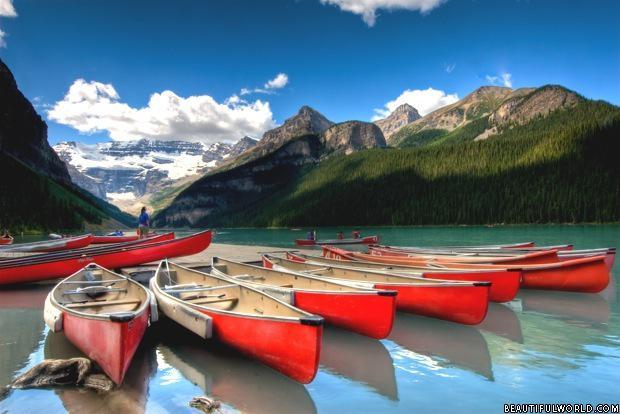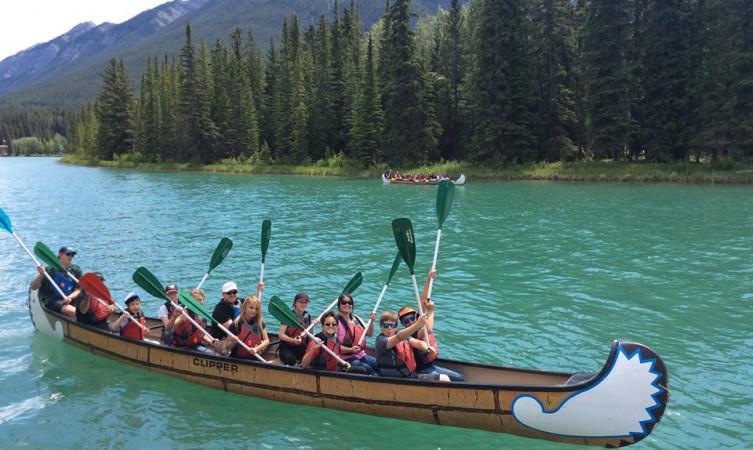The first image is the image on the left, the second image is the image on the right. Evaluate the accuracy of this statement regarding the images: "There is only one red canoe.". Is it true? Answer yes or no. No. The first image is the image on the left, the second image is the image on the right. For the images shown, is this caption "In one image there is a red boat with two people and the other image is a empty boat floating on the water." true? Answer yes or no. No. 